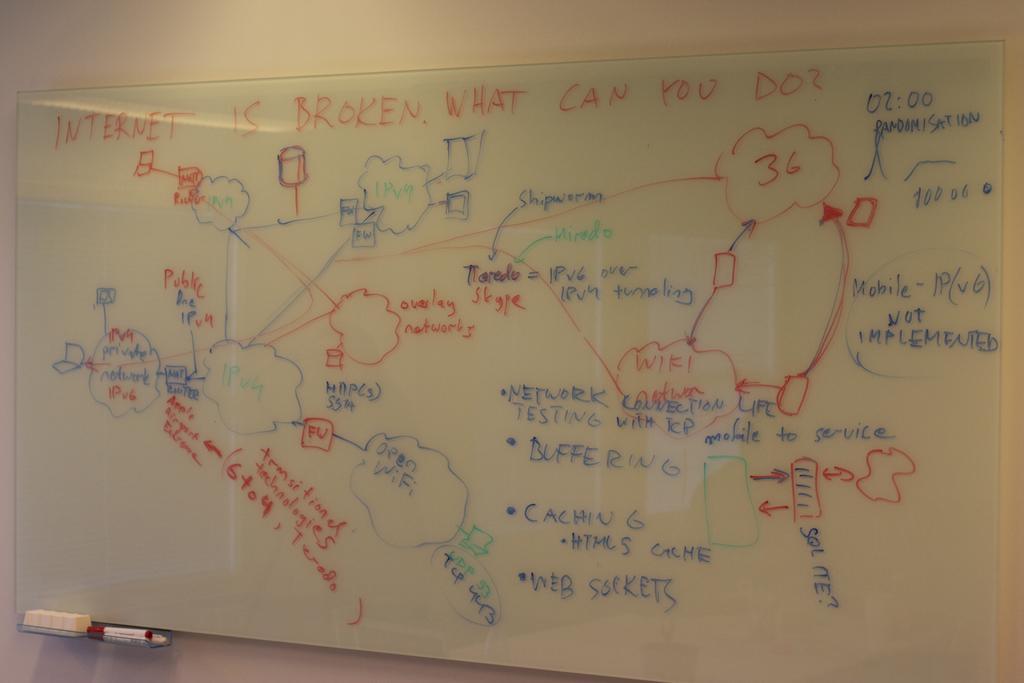Describe this image in one or two sentences. In this image we can see one big whiteboard with text attached to the wall, one marker and duster attached to the whiteboard. 